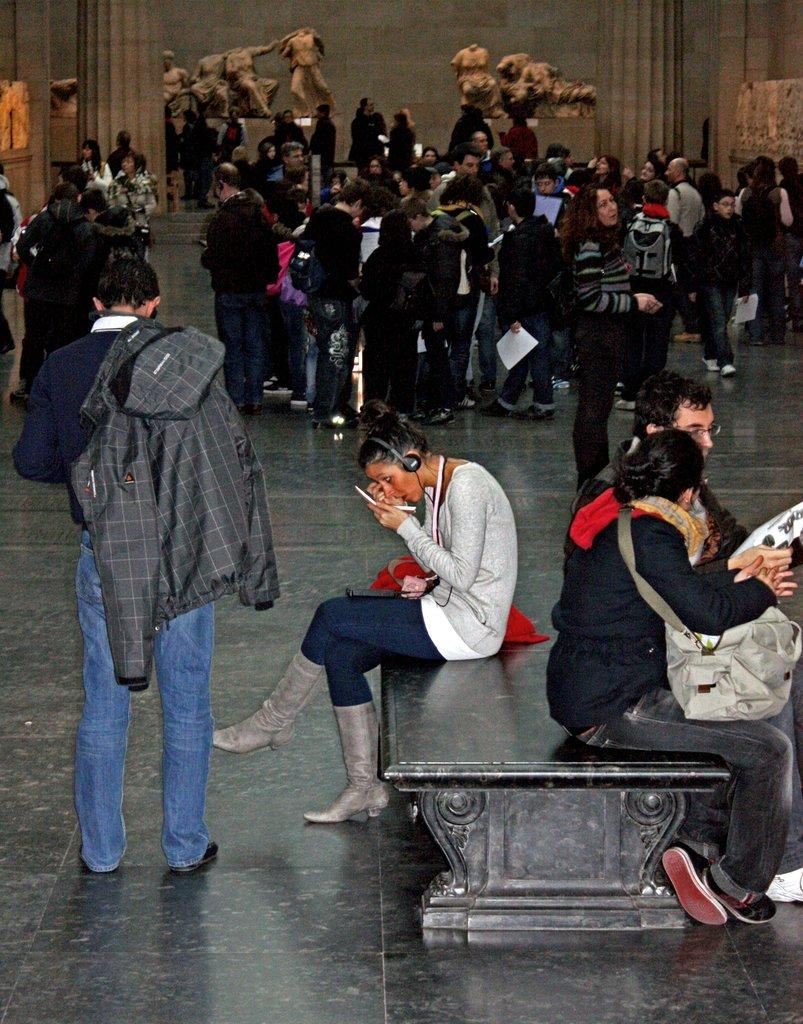How many people are in the image? There are people in the image, but the exact number is not specified. What are the people doing in the image? Some people are sitting on an object in the image. What can be seen on the ground in the image? The ground is visible in the image. What type of structures are present in the image? There are statues and pillars in the image. What type of architectural feature is visible in the image? There is a wall visible in the image. How many houses can be seen in the image? There are no houses visible in the image. What type of woman is depicted in the image? There is no woman depicted in the image. 